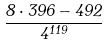Convert formula to latex. <formula><loc_0><loc_0><loc_500><loc_500>\frac { 8 \cdot 3 9 6 - 4 9 2 } { 4 ^ { 1 1 9 } }</formula> 